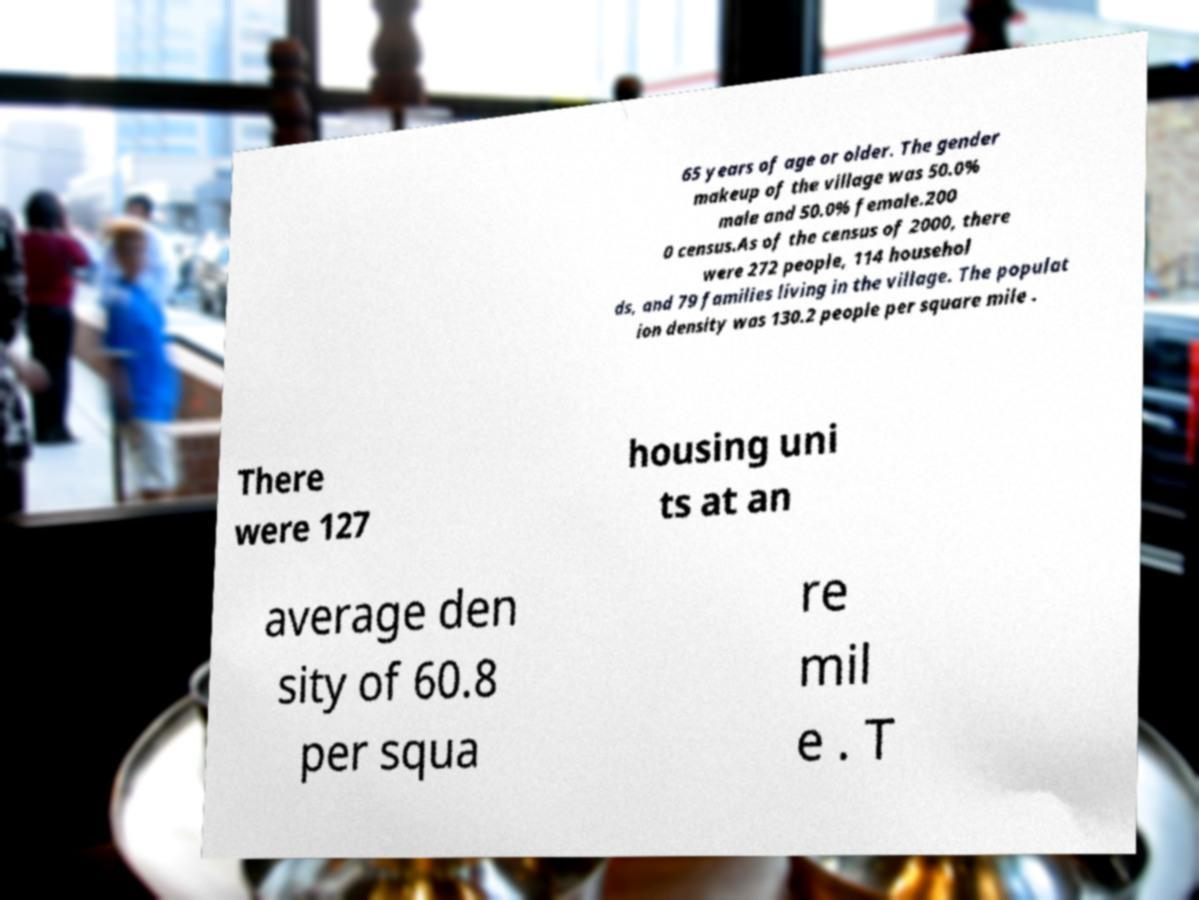Please identify and transcribe the text found in this image. 65 years of age or older. The gender makeup of the village was 50.0% male and 50.0% female.200 0 census.As of the census of 2000, there were 272 people, 114 househol ds, and 79 families living in the village. The populat ion density was 130.2 people per square mile . There were 127 housing uni ts at an average den sity of 60.8 per squa re mil e . T 